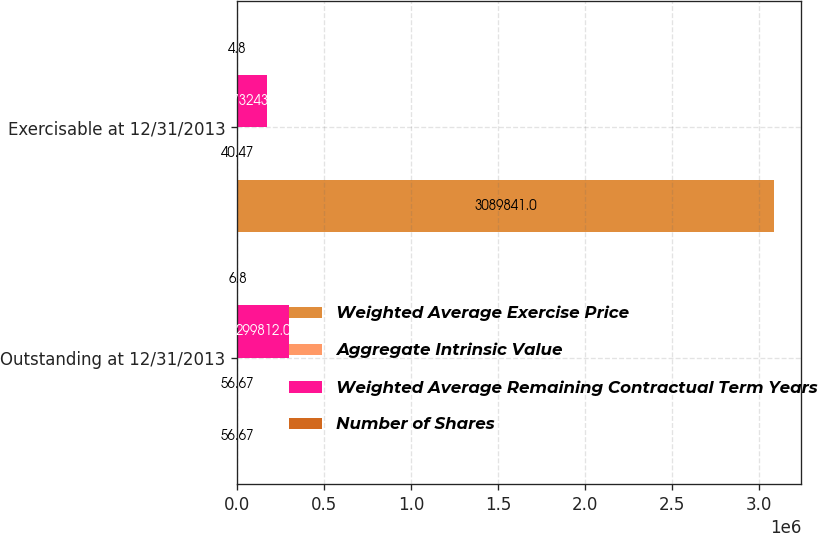Convert chart. <chart><loc_0><loc_0><loc_500><loc_500><stacked_bar_chart><ecel><fcel>Outstanding at 12/31/2013<fcel>Exercisable at 12/31/2013<nl><fcel>Weighted Average Exercise Price<fcel>56.67<fcel>3.08984e+06<nl><fcel>Aggregate Intrinsic Value<fcel>56.67<fcel>40.47<nl><fcel>Weighted Average Remaining Contractual Term Years<fcel>299812<fcel>173243<nl><fcel>Number of Shares<fcel>6.8<fcel>4.8<nl></chart> 